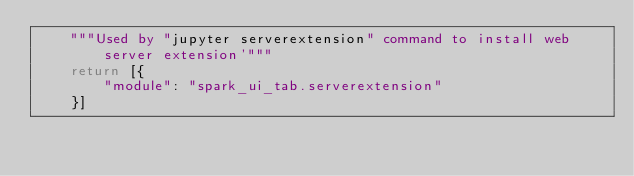<code> <loc_0><loc_0><loc_500><loc_500><_Python_>    """Used by "jupyter serverextension" command to install web server extension'"""
    return [{
        "module": "spark_ui_tab.serverextension"
    }]
</code> 